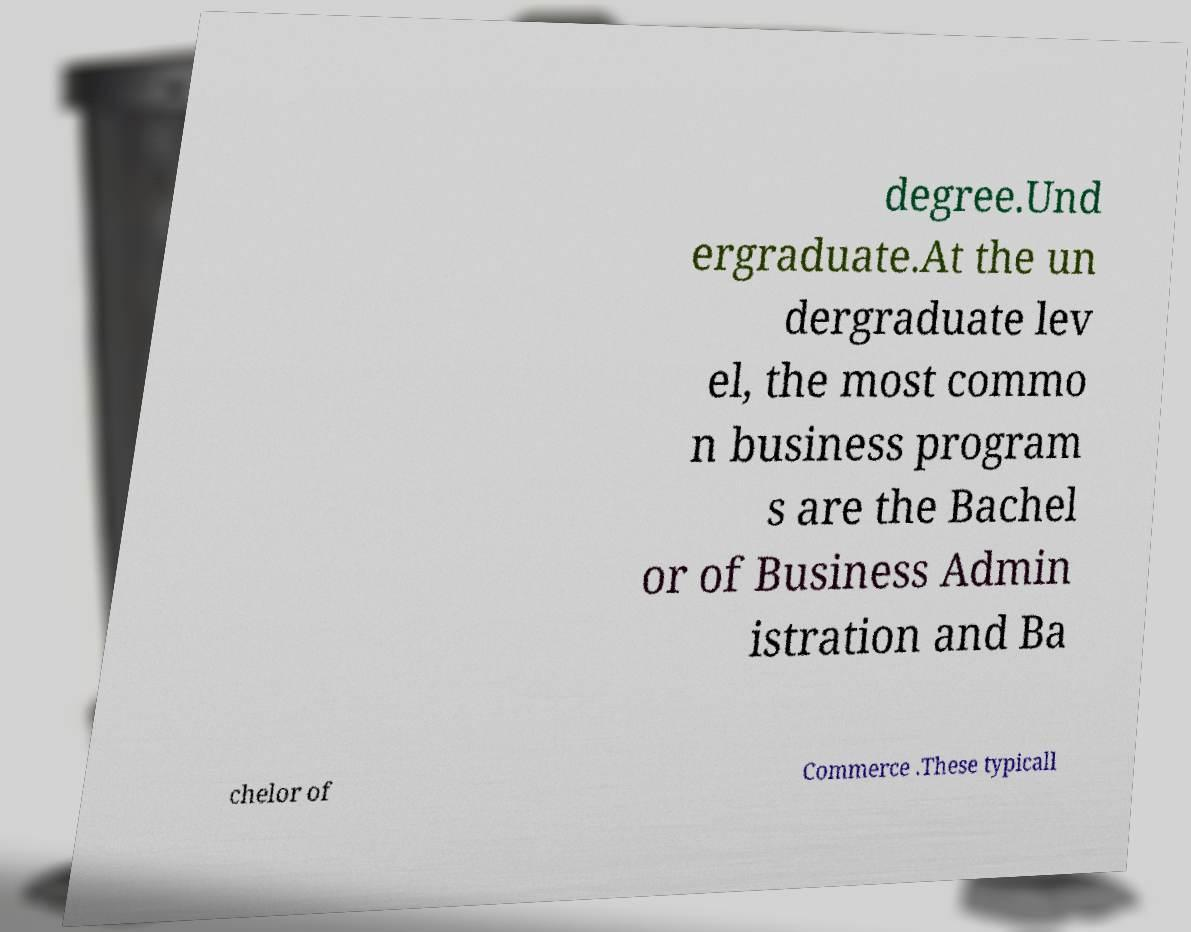I need the written content from this picture converted into text. Can you do that? degree.Und ergraduate.At the un dergraduate lev el, the most commo n business program s are the Bachel or of Business Admin istration and Ba chelor of Commerce .These typicall 